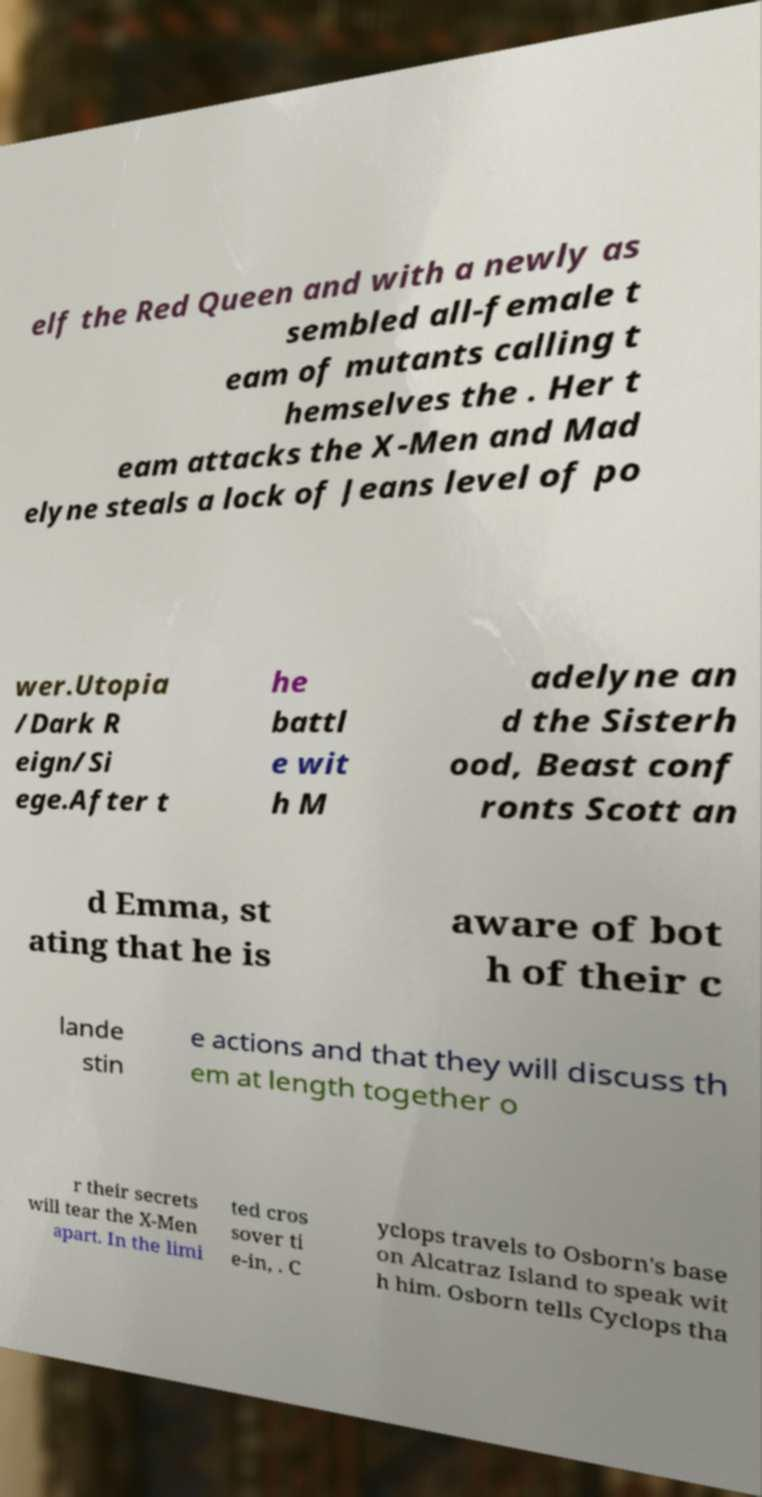Could you extract and type out the text from this image? elf the Red Queen and with a newly as sembled all-female t eam of mutants calling t hemselves the . Her t eam attacks the X-Men and Mad elyne steals a lock of Jeans level of po wer.Utopia /Dark R eign/Si ege.After t he battl e wit h M adelyne an d the Sisterh ood, Beast conf ronts Scott an d Emma, st ating that he is aware of bot h of their c lande stin e actions and that they will discuss th em at length together o r their secrets will tear the X-Men apart. In the limi ted cros sover ti e-in, . C yclops travels to Osborn's base on Alcatraz Island to speak wit h him. Osborn tells Cyclops tha 